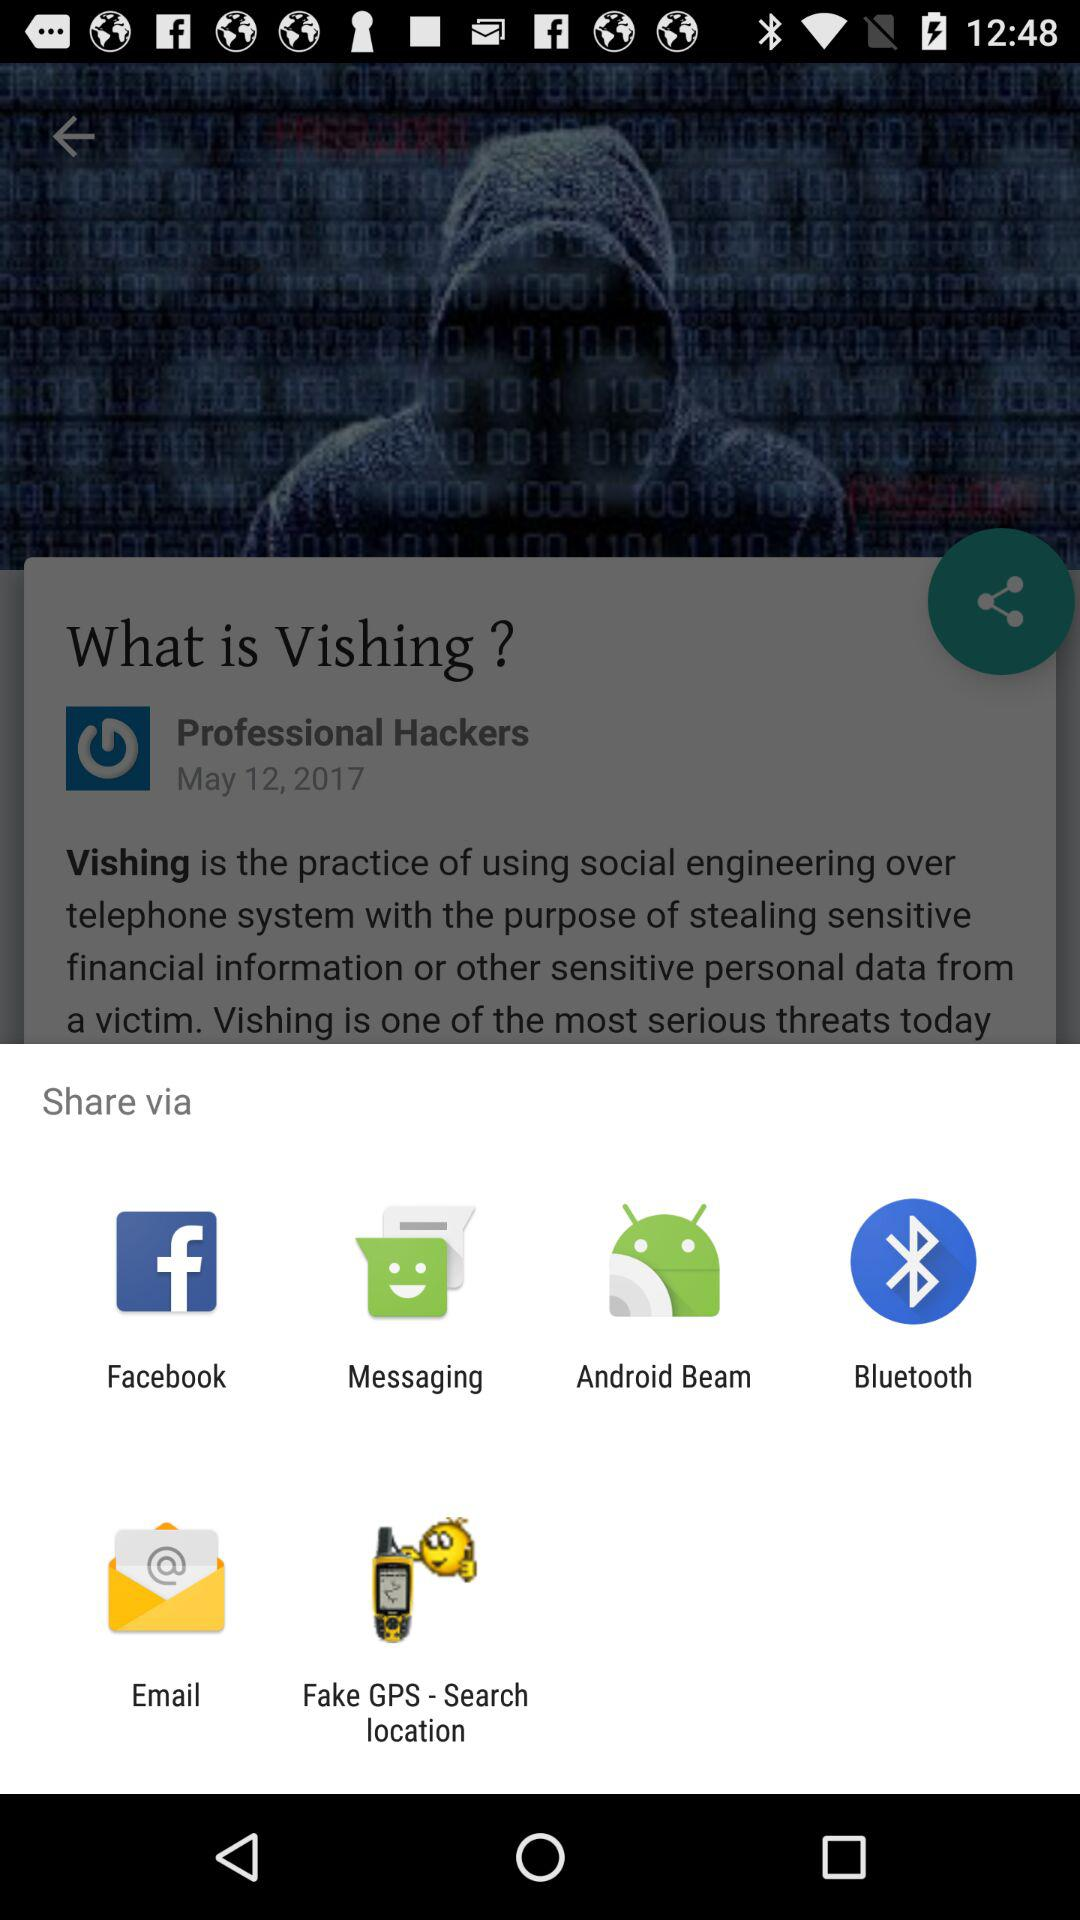Through which app can I share? You can share through "Facebook", "Messaging", "Android Beam", "Bluetooth", "Email" and "Fake GPS - Search location". 